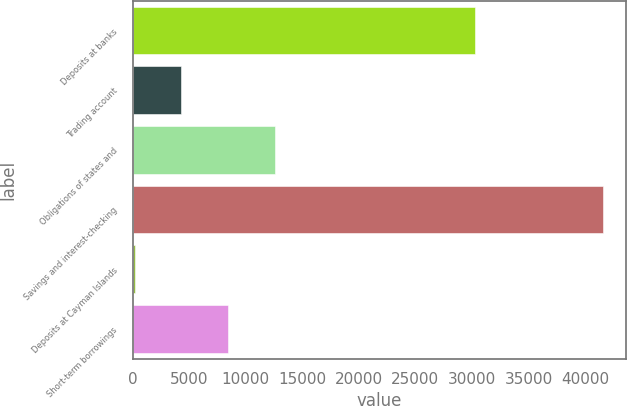Convert chart to OTSL. <chart><loc_0><loc_0><loc_500><loc_500><bar_chart><fcel>Deposits at banks<fcel>Trading account<fcel>Obligations of states and<fcel>Savings and interest-checking<fcel>Deposits at Cayman Islands<fcel>Short-term borrowings<nl><fcel>30264<fcel>4320.2<fcel>12596.6<fcel>41564<fcel>182<fcel>8458.4<nl></chart> 